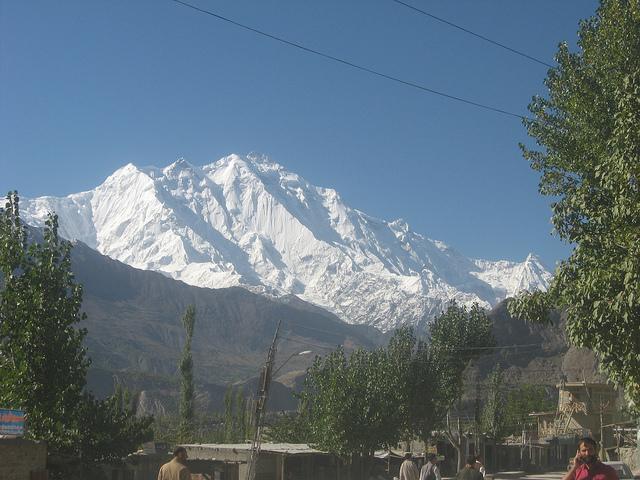Why is there snow up there?
Pick the right solution, then justify: 'Answer: answer
Rationale: rationale.'
Options: Storm coming, high altitude, is mirage, not shoveled. Answer: high altitude.
Rationale: The mountains appear quite tall and mountains at this height are known to have snow at the top 